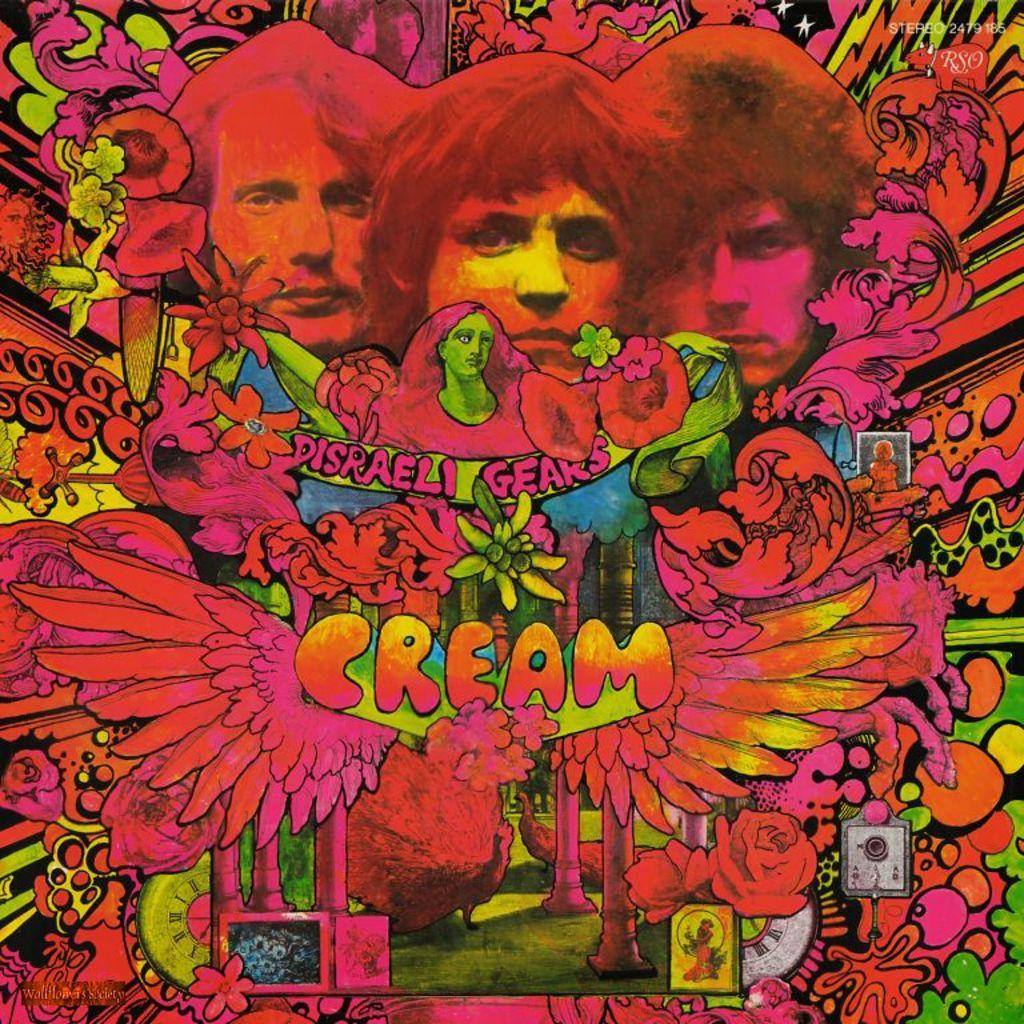<image>
Create a compact narrative representing the image presented. A colorful design shows several men with the text Cream on it. 